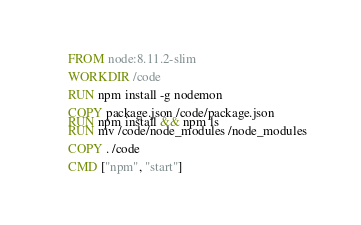<code> <loc_0><loc_0><loc_500><loc_500><_Dockerfile_>FROM node:8.11.2-slim

WORKDIR /code

RUN npm install -g nodemon

COPY package.json /code/package.json
RUN npm install && npm ls
RUN mv /code/node_modules /node_modules

COPY . /code

CMD ["npm", "start"]</code> 